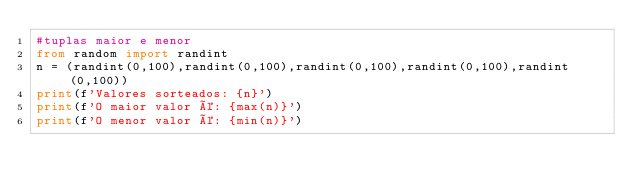Convert code to text. <code><loc_0><loc_0><loc_500><loc_500><_Python_>#tuplas maior e menor
from random import randint
n = (randint(0,100),randint(0,100),randint(0,100),randint(0,100),randint(0,100))
print(f'Valores sorteados: {n}')
print(f'O maior valor é: {max(n)}')
print(f'O menor valor é: {min(n)}')</code> 